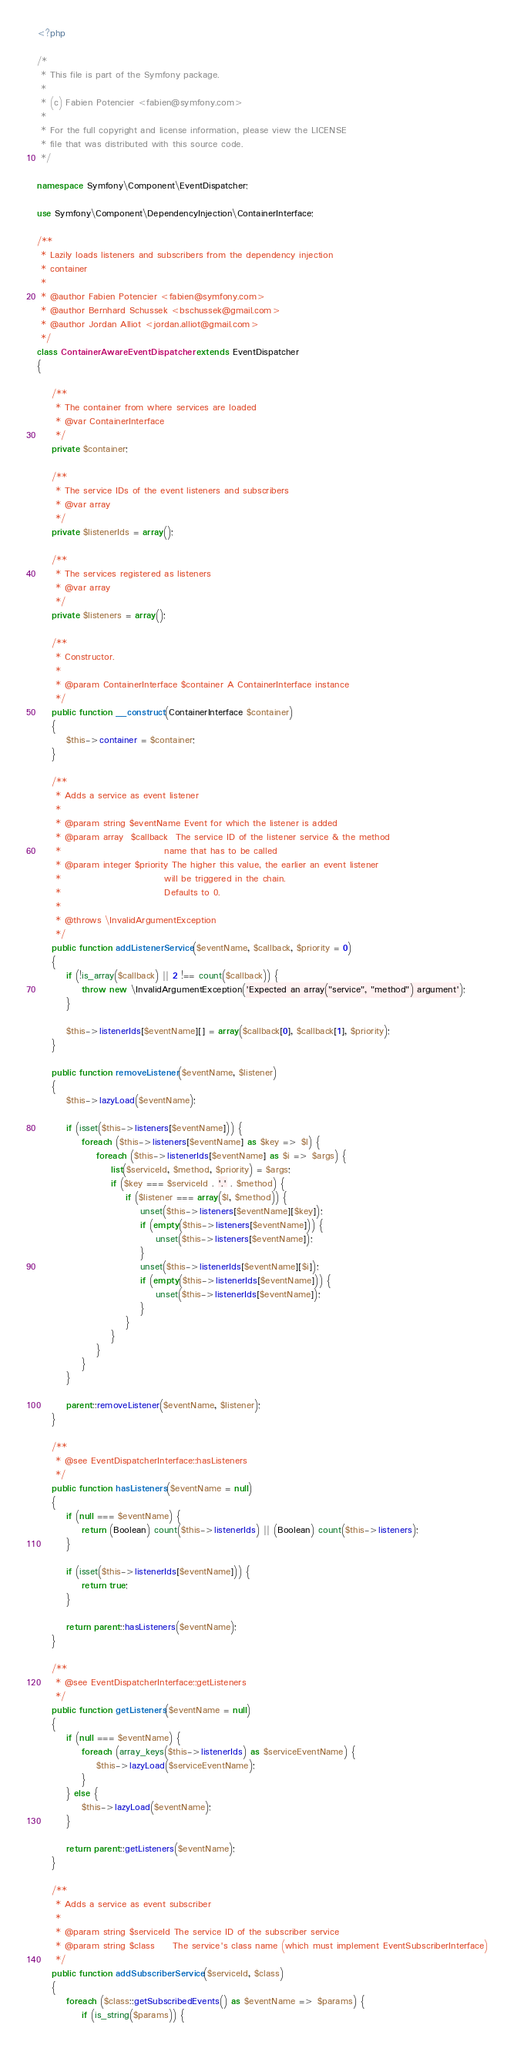<code> <loc_0><loc_0><loc_500><loc_500><_PHP_><?php

/*
 * This file is part of the Symfony package.
 *
 * (c) Fabien Potencier <fabien@symfony.com>
 *
 * For the full copyright and license information, please view the LICENSE
 * file that was distributed with this source code.
 */

namespace Symfony\Component\EventDispatcher;

use Symfony\Component\DependencyInjection\ContainerInterface;

/**
 * Lazily loads listeners and subscribers from the dependency injection
 * container
 *
 * @author Fabien Potencier <fabien@symfony.com>
 * @author Bernhard Schussek <bschussek@gmail.com>
 * @author Jordan Alliot <jordan.alliot@gmail.com>
 */
class ContainerAwareEventDispatcher extends EventDispatcher
{

    /**
     * The container from where services are loaded
     * @var ContainerInterface
     */
    private $container;

    /**
     * The service IDs of the event listeners and subscribers
     * @var array
     */
    private $listenerIds = array();

    /**
     * The services registered as listeners
     * @var array
     */
    private $listeners = array();

    /**
     * Constructor.
     *
     * @param ContainerInterface $container A ContainerInterface instance
     */
    public function __construct(ContainerInterface $container)
    {
        $this->container = $container;
    }

    /**
     * Adds a service as event listener
     *
     * @param string $eventName Event for which the listener is added
     * @param array  $callback  The service ID of the listener service & the method
     *                            name that has to be called
     * @param integer $priority The higher this value, the earlier an event listener
     *                            will be triggered in the chain.
     *                            Defaults to 0.
     *
     * @throws \InvalidArgumentException
     */
    public function addListenerService($eventName, $callback, $priority = 0)
    {
        if (!is_array($callback) || 2 !== count($callback)) {
            throw new \InvalidArgumentException('Expected an array("service", "method") argument');
        }

        $this->listenerIds[$eventName][] = array($callback[0], $callback[1], $priority);
    }

    public function removeListener($eventName, $listener)
    {
        $this->lazyLoad($eventName);

        if (isset($this->listeners[$eventName])) {
            foreach ($this->listeners[$eventName] as $key => $l) {
                foreach ($this->listenerIds[$eventName] as $i => $args) {
                    list($serviceId, $method, $priority) = $args;
                    if ($key === $serviceId . '.' . $method) {
                        if ($listener === array($l, $method)) {
                            unset($this->listeners[$eventName][$key]);
                            if (empty($this->listeners[$eventName])) {
                                unset($this->listeners[$eventName]);
                            }
                            unset($this->listenerIds[$eventName][$i]);
                            if (empty($this->listenerIds[$eventName])) {
                                unset($this->listenerIds[$eventName]);
                            }
                        }
                    }
                }
            }
        }

        parent::removeListener($eventName, $listener);
    }

    /**
     * @see EventDispatcherInterface::hasListeners
     */
    public function hasListeners($eventName = null)
    {
        if (null === $eventName) {
            return (Boolean) count($this->listenerIds) || (Boolean) count($this->listeners);
        }

        if (isset($this->listenerIds[$eventName])) {
            return true;
        }

        return parent::hasListeners($eventName);
    }

    /**
     * @see EventDispatcherInterface::getListeners
     */
    public function getListeners($eventName = null)
    {
        if (null === $eventName) {
            foreach (array_keys($this->listenerIds) as $serviceEventName) {
                $this->lazyLoad($serviceEventName);
            }
        } else {
            $this->lazyLoad($eventName);
        }

        return parent::getListeners($eventName);
    }

    /**
     * Adds a service as event subscriber
     *
     * @param string $serviceId The service ID of the subscriber service
     * @param string $class     The service's class name (which must implement EventSubscriberInterface)
     */
    public function addSubscriberService($serviceId, $class)
    {
        foreach ($class::getSubscribedEvents() as $eventName => $params) {
            if (is_string($params)) {</code> 